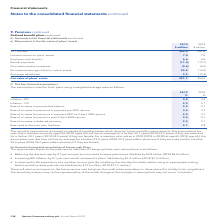According to Spirent Communications Plc's financial document, What does the table record movements in? the fair value of plans’ assets. The document states: "he financial statements continued e) Movements in the fair value of plans’ assets..." Also, What is the fair value of plans' assets in 2019? According to the financial document, 291.1 (in millions). The relevant text states: "Fair value of plans’ assets 291.1 254.2..." Also, In which years are the movements in the fair value of plans' assets recorded? The document shows two values: 2019 and 2018. From the document: "138 Spirent Communications plc Annual Report 2019 2018 $ million..." Additionally, In which year were the employer contributions larger? According to the financial document, 2018. The relevant text states: "2018 $ million..." Also, can you calculate: What was the change in the fair value of plans' assets? Based on the calculation: 291.1-254.2, the result is 36.9 (in millions). This is based on the information: "Fair value of plans’ assets 291.1 254.2 Fair value of plans’ assets 291.1 254.2..." The key data points involved are: 254.2, 291.1. Also, can you calculate: What was the percentage change in the fair value of plans' assets? To answer this question, I need to perform calculations using the financial data. The calculation is: (291.1-254.2)/254.2, which equals 14.52 (percentage). This is based on the information: "Fair value of plans’ assets 291.1 254.2 Fair value of plans’ assets 291.1 254.2..." The key data points involved are: 254.2, 291.1. 